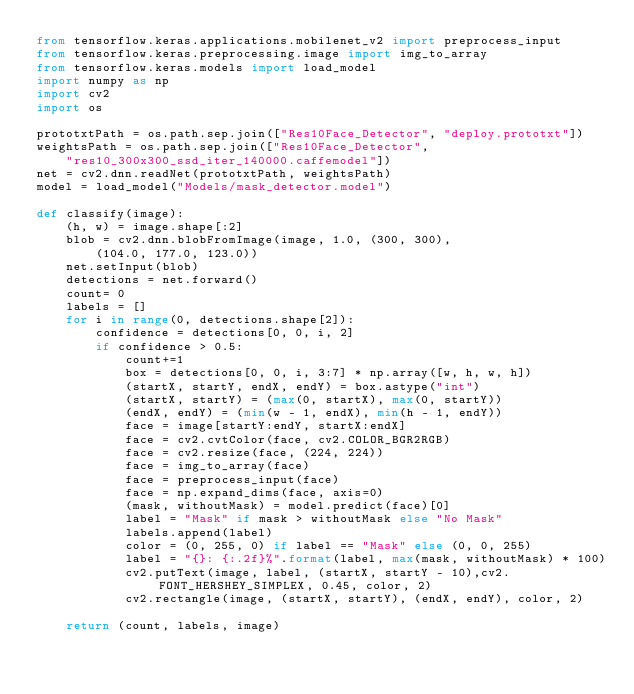Convert code to text. <code><loc_0><loc_0><loc_500><loc_500><_Python_>from tensorflow.keras.applications.mobilenet_v2 import preprocess_input
from tensorflow.keras.preprocessing.image import img_to_array
from tensorflow.keras.models import load_model
import numpy as np
import cv2
import os

prototxtPath = os.path.sep.join(["Res10Face_Detector", "deploy.prototxt"])
weightsPath = os.path.sep.join(["Res10Face_Detector",
    "res10_300x300_ssd_iter_140000.caffemodel"])
net = cv2.dnn.readNet(prototxtPath, weightsPath)
model = load_model("Models/mask_detector.model")

def classify(image):
    (h, w) = image.shape[:2]
    blob = cv2.dnn.blobFromImage(image, 1.0, (300, 300),
        (104.0, 177.0, 123.0))
    net.setInput(blob)
    detections = net.forward()
    count= 0
    labels = []
    for i in range(0, detections.shape[2]):
        confidence = detections[0, 0, i, 2]
        if confidence > 0.5:
            count+=1
            box = detections[0, 0, i, 3:7] * np.array([w, h, w, h])
            (startX, startY, endX, endY) = box.astype("int")
            (startX, startY) = (max(0, startX), max(0, startY))
            (endX, endY) = (min(w - 1, endX), min(h - 1, endY))
            face = image[startY:endY, startX:endX]
            face = cv2.cvtColor(face, cv2.COLOR_BGR2RGB)
            face = cv2.resize(face, (224, 224))
            face = img_to_array(face)
            face = preprocess_input(face)
            face = np.expand_dims(face, axis=0)
            (mask, withoutMask) = model.predict(face)[0]
            label = "Mask" if mask > withoutMask else "No Mask"
            labels.append(label)
            color = (0, 255, 0) if label == "Mask" else (0, 0, 255)
            label = "{}: {:.2f}%".format(label, max(mask, withoutMask) * 100)
            cv2.putText(image, label, (startX, startY - 10),cv2.FONT_HERSHEY_SIMPLEX, 0.45, color, 2)
            cv2.rectangle(image, (startX, startY), (endX, endY), color, 2)

    return (count, labels, image)</code> 